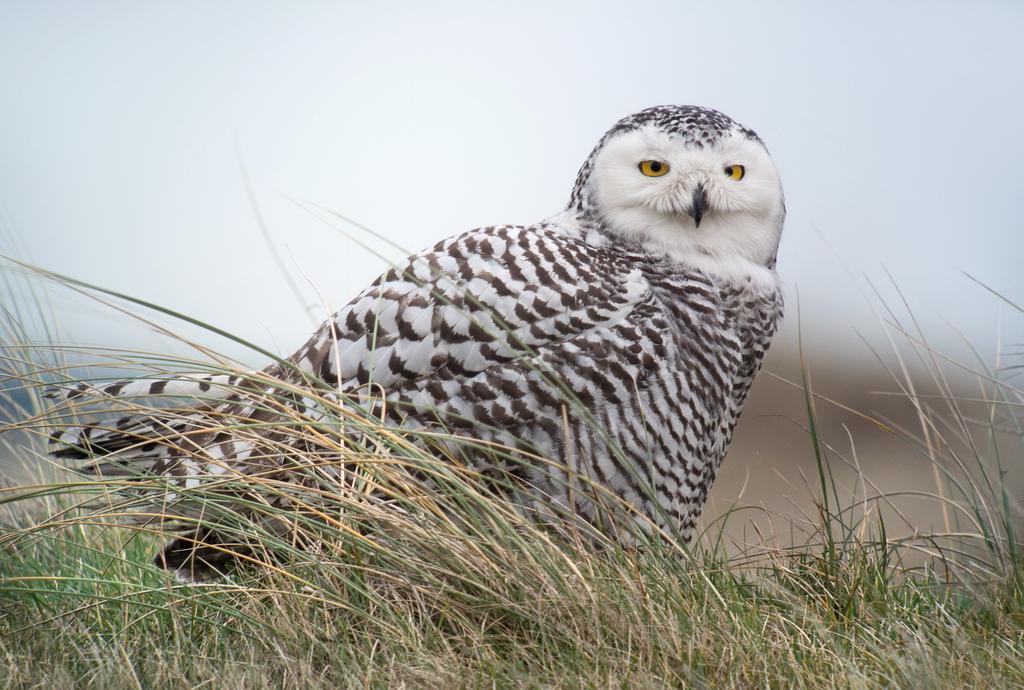Please provide a concise description of this image. In the center of the image there is a owl on the grass. In the background we can see sky. 